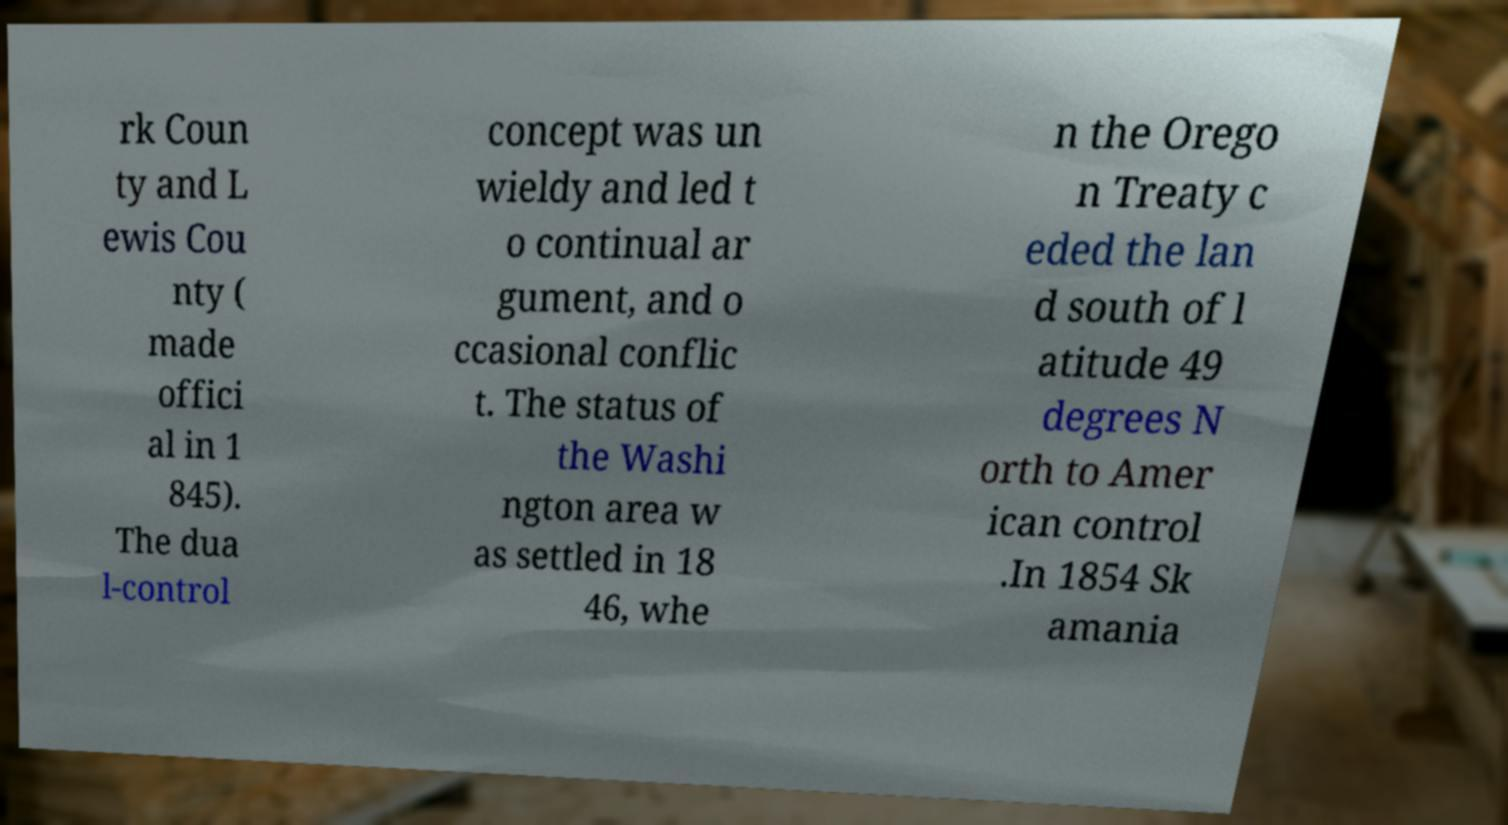Could you extract and type out the text from this image? rk Coun ty and L ewis Cou nty ( made offici al in 1 845). The dua l-control concept was un wieldy and led t o continual ar gument, and o ccasional conflic t. The status of the Washi ngton area w as settled in 18 46, whe n the Orego n Treaty c eded the lan d south of l atitude 49 degrees N orth to Amer ican control .In 1854 Sk amania 